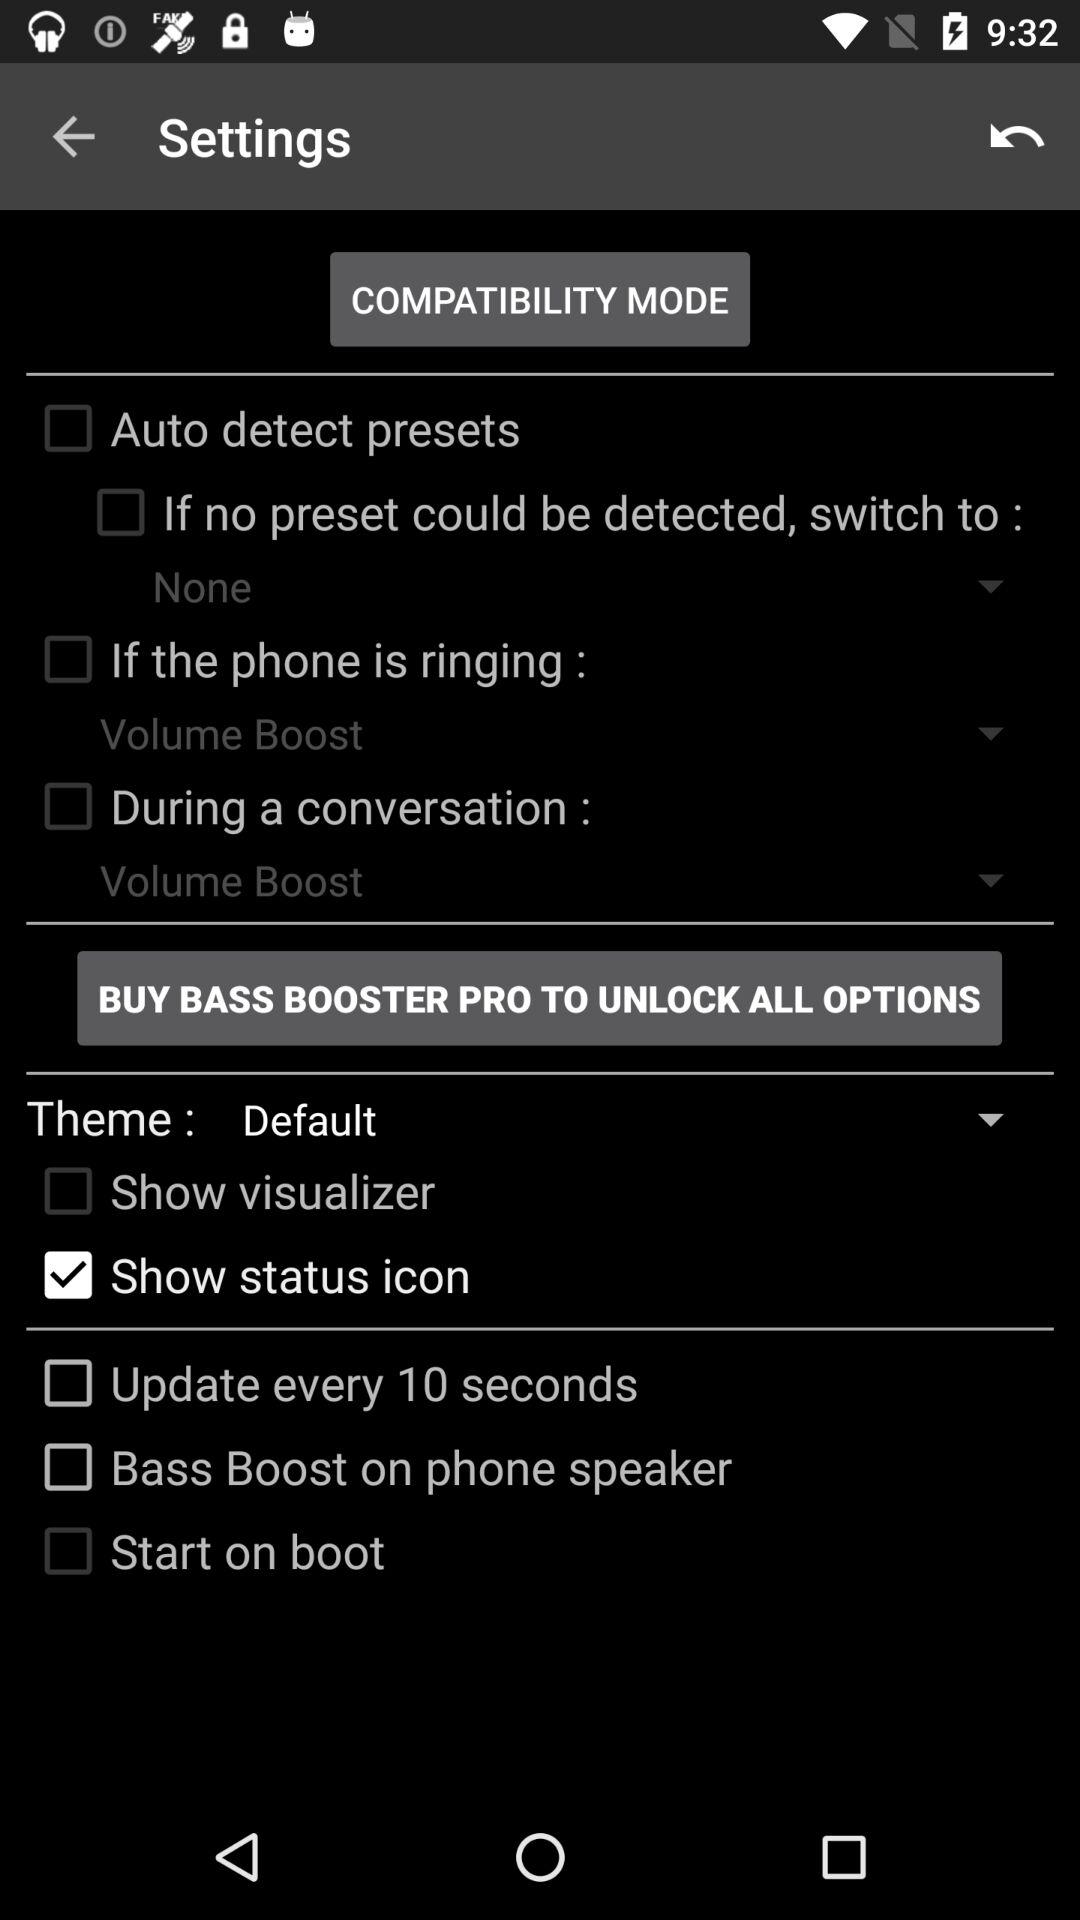What is the theme? The theme is "Default". 